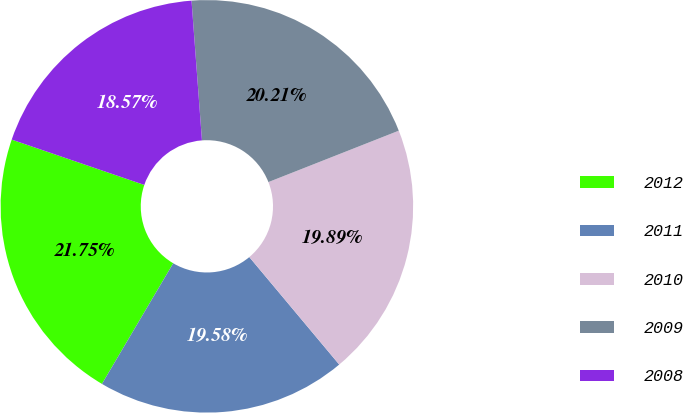Convert chart to OTSL. <chart><loc_0><loc_0><loc_500><loc_500><pie_chart><fcel>2012<fcel>2011<fcel>2010<fcel>2009<fcel>2008<nl><fcel>21.75%<fcel>19.58%<fcel>19.89%<fcel>20.21%<fcel>18.57%<nl></chart> 